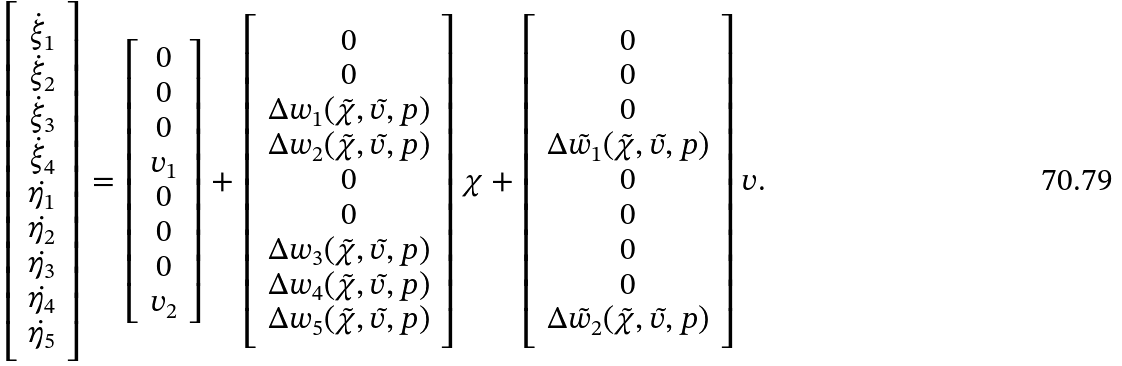Convert formula to latex. <formula><loc_0><loc_0><loc_500><loc_500>\left [ \begin{array} { c } \dot { \xi } _ { 1 } \\ \dot { \xi } _ { 2 } \\ \dot { \xi } _ { 3 } \\ \dot { \xi } _ { 4 } \\ \dot { \eta _ { 1 } } \\ \dot { \eta _ { 2 } } \\ \dot { \eta _ { 3 } } \\ \dot { \eta _ { 4 } } \\ \dot { \eta } _ { 5 } \end{array} \right ] = \left [ \begin{array} { c } 0 \\ 0 \\ 0 \\ v _ { 1 } \\ 0 \\ 0 \\ 0 \\ v _ { 2 } \end{array} \right ] + \left [ \begin{array} { c } 0 \\ 0 \\ \Delta w _ { 1 } ( \tilde { \chi } , \tilde { v } , p ) \\ \Delta w _ { 2 } ( \tilde { \chi } , \tilde { v } , p ) \\ 0 \\ 0 \\ \Delta w _ { 3 } ( \tilde { \chi } , \tilde { v } , p ) \\ \Delta w _ { 4 } ( \tilde { \chi } , \tilde { v } , p ) \\ \Delta w _ { 5 } ( \tilde { \chi } , \tilde { v } , p ) \end{array} \right ] \chi + \left [ \begin{array} { c } 0 \\ 0 \\ 0 \\ \Delta \tilde { w } _ { 1 } ( \tilde { \chi } , \tilde { v } , p ) \\ 0 \\ 0 \\ 0 \\ 0 \\ \Delta \tilde { w } _ { 2 } ( \tilde { \chi } , \tilde { v } , p ) \end{array} \right ] v .</formula> 